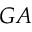Convert formula to latex. <formula><loc_0><loc_0><loc_500><loc_500>G A</formula> 